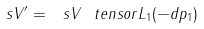Convert formula to latex. <formula><loc_0><loc_0><loc_500><loc_500>\ s V ^ { \prime } = \ s V \ t e n s o r L _ { 1 } ( - d p _ { 1 } )</formula> 